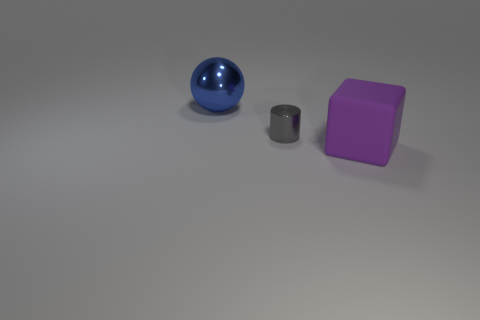There is a big ball that is made of the same material as the small thing; what is its color?
Provide a succinct answer. Blue. What is the shape of the rubber object that is the same size as the shiny sphere?
Your response must be concise. Cube. What is the size of the object that is in front of the metallic thing right of the sphere?
Provide a succinct answer. Large. Is the size of the metallic object behind the gray cylinder the same as the small cylinder?
Your response must be concise. No. Are there more big shiny balls left of the big purple matte block than big rubber blocks that are behind the small gray cylinder?
Keep it short and to the point. Yes. There is a big thing that is right of the big blue thing; what shape is it?
Your response must be concise. Cube. There is a shiny object on the right side of the shiny thing that is behind the metallic thing in front of the large blue metal sphere; how big is it?
Give a very brief answer. Small. Is the small thing the same shape as the large metal object?
Your answer should be very brief. No. There is a object that is behind the purple matte cube and in front of the metallic ball; how big is it?
Offer a terse response. Small. There is a big object in front of the object left of the gray metallic thing; what is its material?
Offer a terse response. Rubber. 